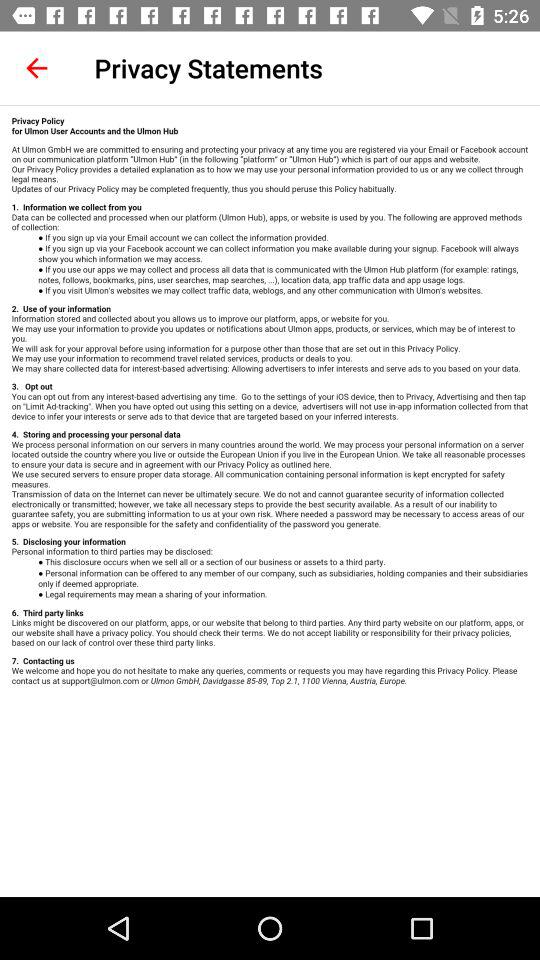How many sections are there in the privacy policy?
Answer the question using a single word or phrase. 7 